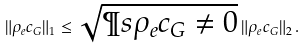<formula> <loc_0><loc_0><loc_500><loc_500>\| \rho _ { e } c _ { G } \| _ { 1 } \leq \sqrt { \P s { \rho _ { e } c _ { G } \ne 0 } } \, \| \rho _ { e } c _ { G } \| _ { 2 } \, .</formula> 